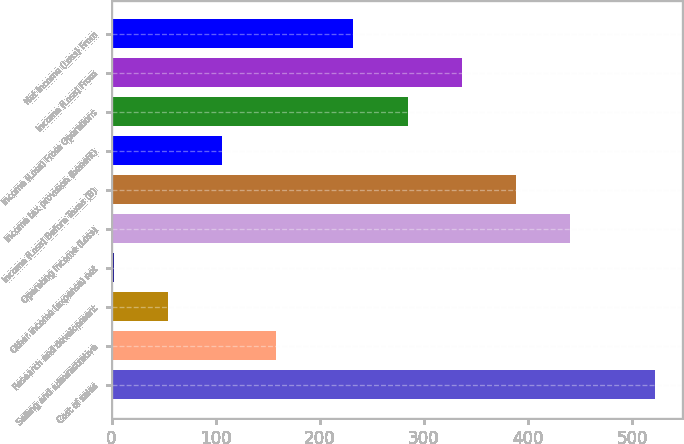Convert chart to OTSL. <chart><loc_0><loc_0><loc_500><loc_500><bar_chart><fcel>Cost of sales<fcel>Selling and administrative<fcel>Research and development<fcel>Other income (expense) net<fcel>Operating Income (Loss)<fcel>Income (Loss) Before Taxes (B)<fcel>Income tax provision (benefit)<fcel>Income (Loss) From Operations<fcel>Income (Loss) From<fcel>Net Income (Loss) From<nl><fcel>521.6<fcel>158.02<fcel>54.14<fcel>2.2<fcel>440.06<fcel>388.12<fcel>106.08<fcel>284.24<fcel>336.18<fcel>232.3<nl></chart> 